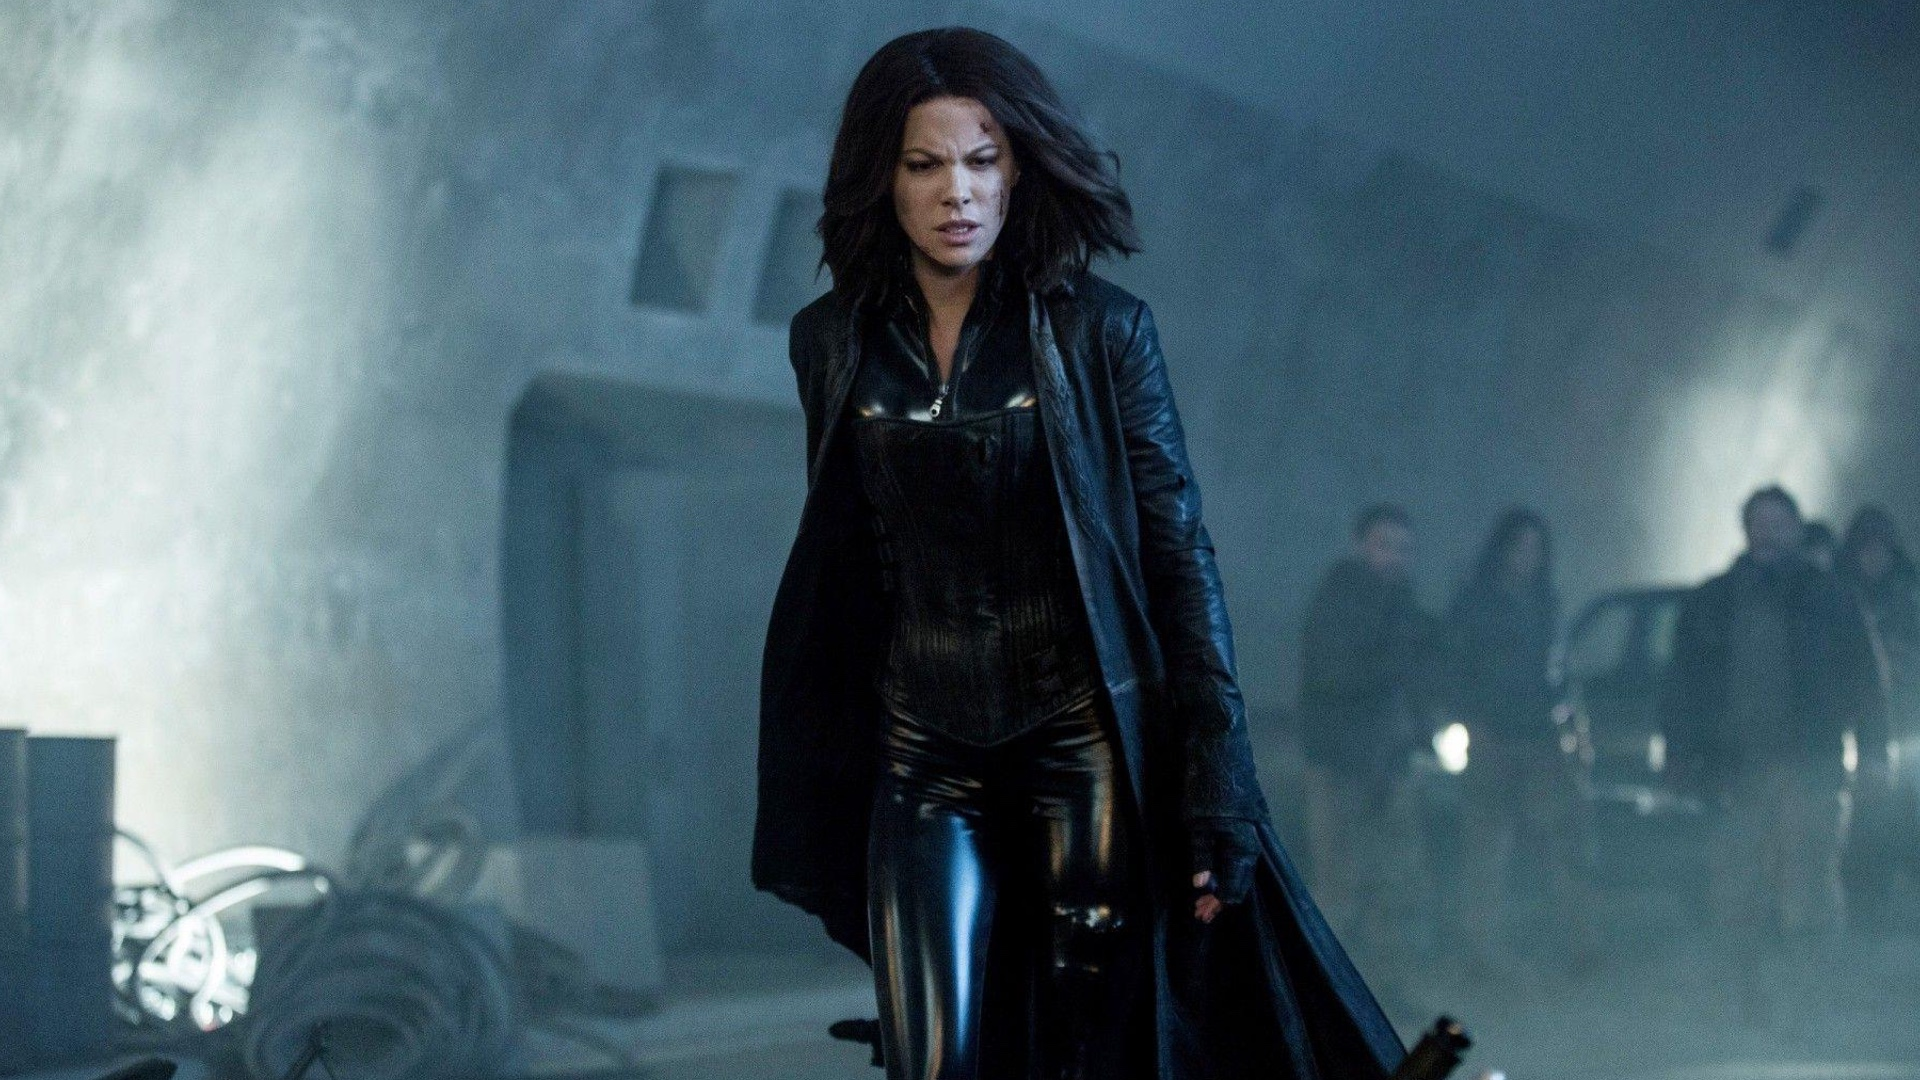What are the key elements in this picture? The image features Kate Beckinsale portraying her character, Selene, from the Underworld film series. She is captured mid-stride, projecting determination and strength. Selene is dressed in a distinctive black leather outfit, including a long coat and high boots, which is her character's signature look. The setting is industrial and shrouded in fog, enhancing the dark and moody atmosphere synonymous with the Underworld series. In the background, indistinct figures and objects can be seen, contributing to the overall gothic aesthetic. 